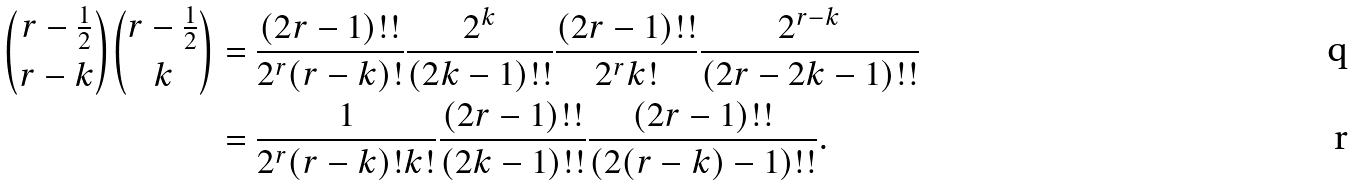<formula> <loc_0><loc_0><loc_500><loc_500>\binom { r - \frac { 1 } { 2 } } { r - k } \binom { r - \frac { 1 } { 2 } } { k } & = \frac { ( 2 r - 1 ) ! ! } { 2 ^ { r } ( r - k ) ! } \frac { 2 ^ { k } } { ( 2 k - 1 ) ! ! } \frac { ( 2 r - 1 ) ! ! } { 2 ^ { r } k ! } \frac { 2 ^ { r - k } } { ( 2 r - 2 k - 1 ) ! ! } \\ & = \frac { 1 } { 2 ^ { r } ( r - k ) ! k ! } \frac { ( 2 r - 1 ) ! ! } { ( 2 k - 1 ) ! ! } \frac { ( 2 r - 1 ) ! ! } { ( 2 ( r - k ) - 1 ) ! ! } .</formula> 